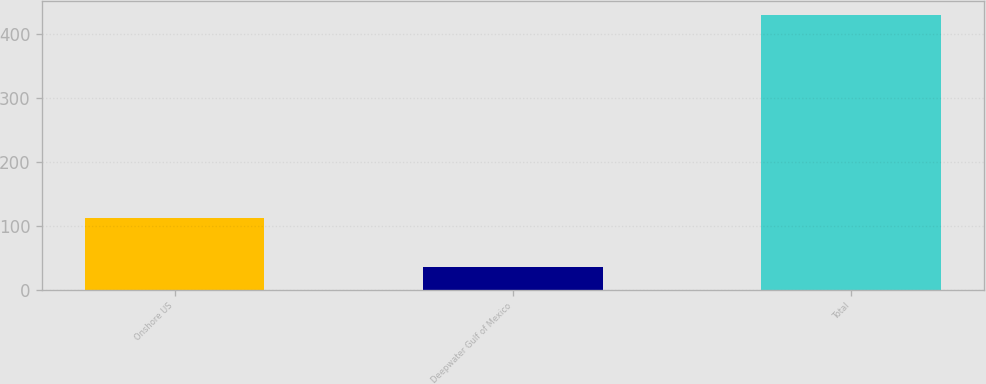Convert chart to OTSL. <chart><loc_0><loc_0><loc_500><loc_500><bar_chart><fcel>Onshore US<fcel>Deepwater Gulf of Mexico<fcel>Total<nl><fcel>113<fcel>36<fcel>429<nl></chart> 